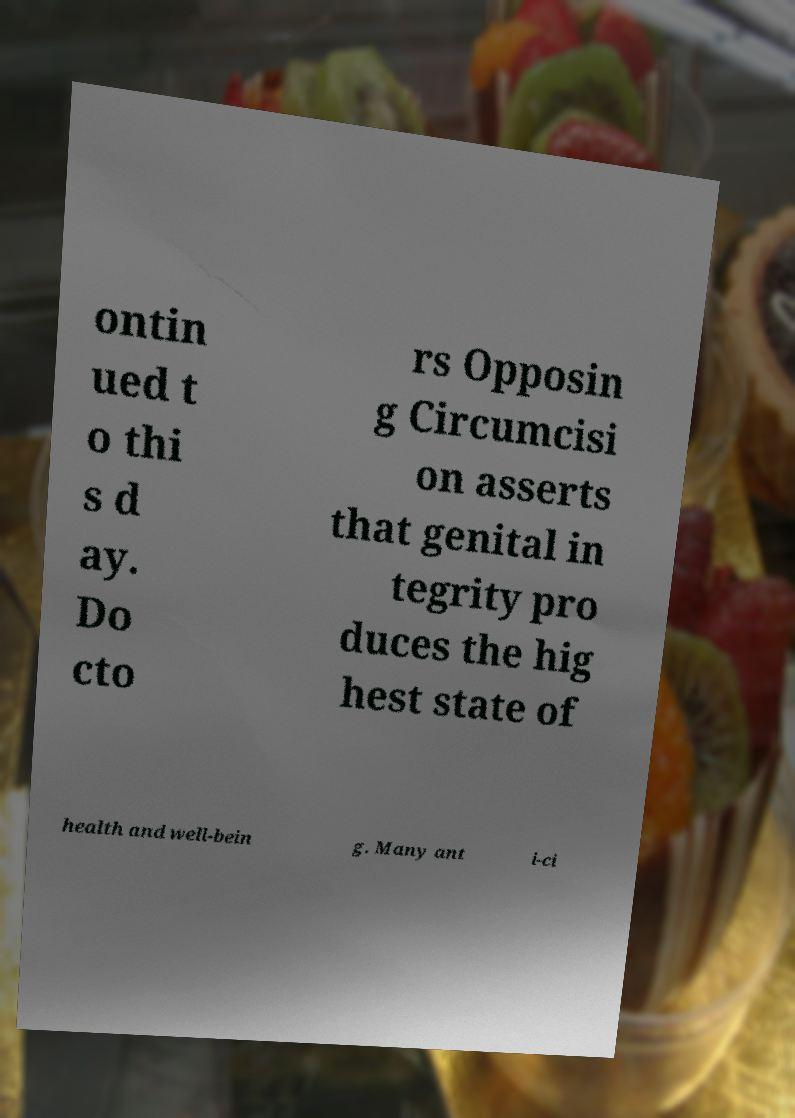Could you extract and type out the text from this image? ontin ued t o thi s d ay. Do cto rs Opposin g Circumcisi on asserts that genital in tegrity pro duces the hig hest state of health and well-bein g. Many ant i-ci 